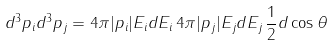<formula> <loc_0><loc_0><loc_500><loc_500>d ^ { 3 } { p } _ { i } d ^ { 3 } { p } _ { j } = 4 \pi | { p } _ { i } | E _ { i } d E _ { i } \, 4 \pi | { p } _ { j } | E _ { j } d E _ { j } \, \frac { 1 } { 2 } d \cos \theta</formula> 